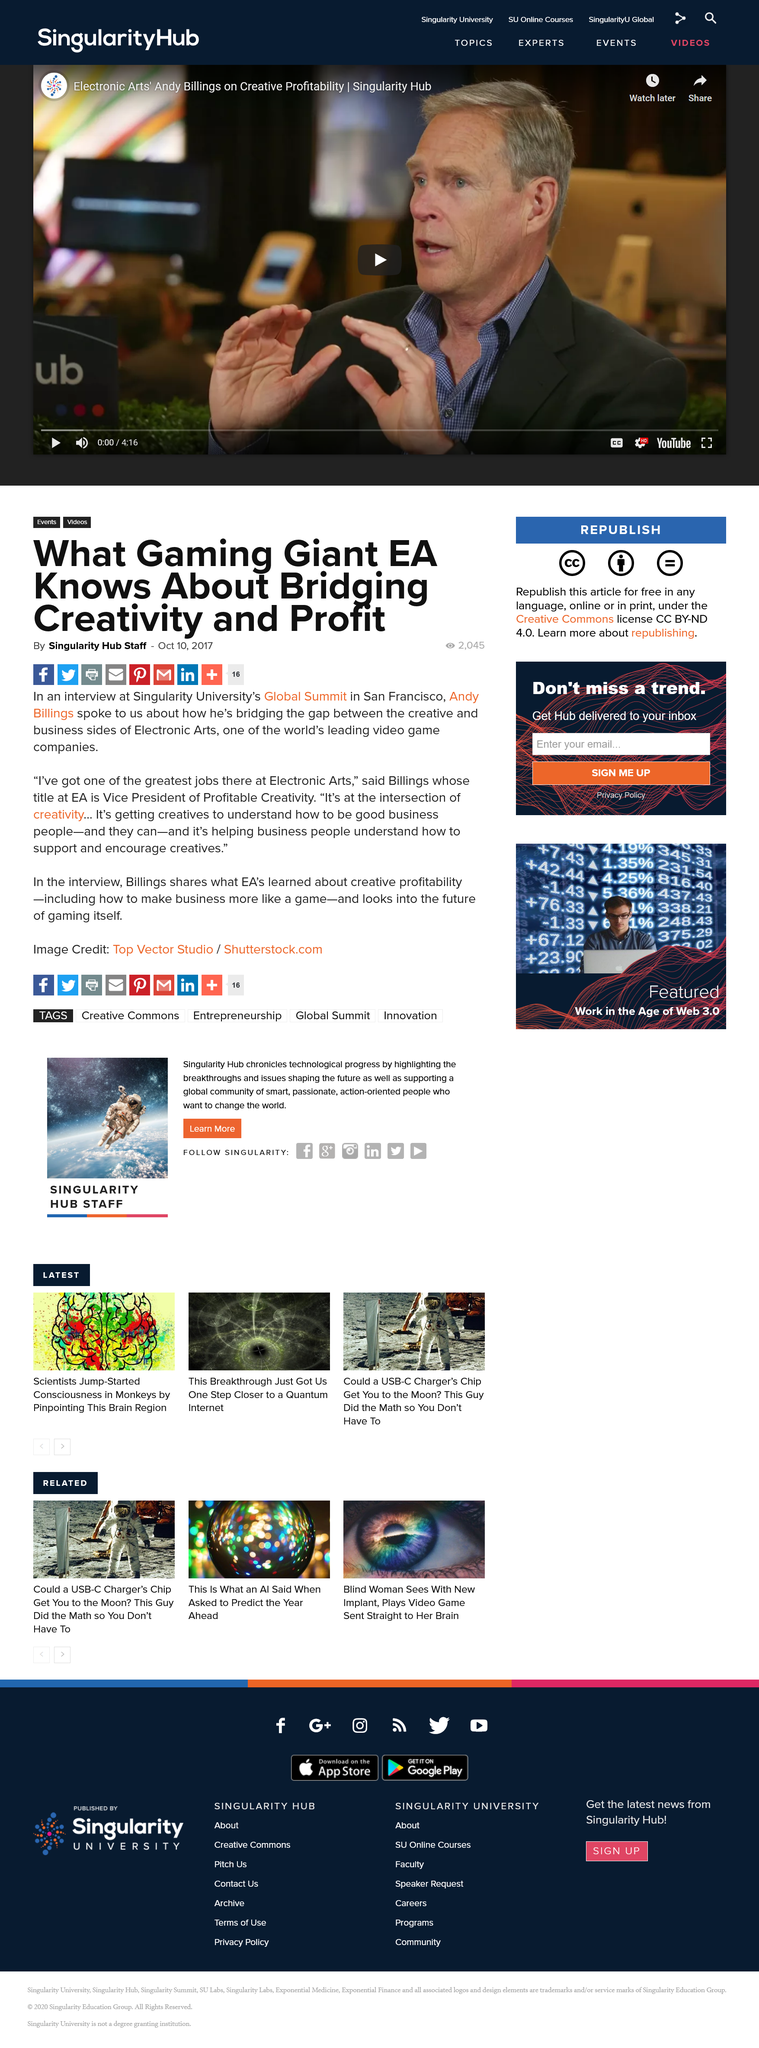Specify some key components in this picture. Andy Billing holds the title of Vice President of Profitable Creativity at Electronic Arts. Andy Billings is the Vice President of Profitable Creativity at Electronic Arts. Andy Billing is the Vice President of Profitable Creativity at Electronic Arts. 